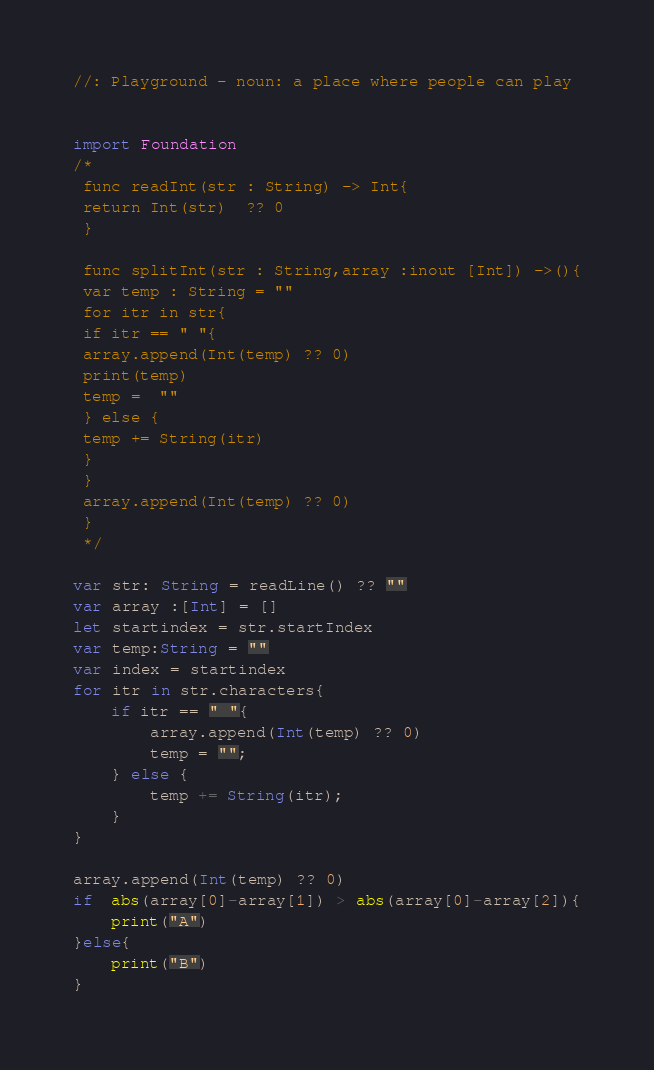<code> <loc_0><loc_0><loc_500><loc_500><_Swift_>//: Playground - noun: a place where people can play


import Foundation
/*
 func readInt(str : String) -> Int{
 return Int(str)  ?? 0
 }
 
 func splitInt(str : String,array :inout [Int]) ->(){
 var temp : String = ""
 for itr in str{
 if itr == " "{
 array.append(Int(temp) ?? 0)
 print(temp)
 temp =  ""
 } else {
 temp += String(itr)
 }
 }
 array.append(Int(temp) ?? 0)
 }
 */

var str: String = readLine() ?? ""
var array :[Int] = []
let startindex = str.startIndex
var temp:String = ""
var index = startindex
for itr in str.characters{
    if itr == " "{
        array.append(Int(temp) ?? 0)
        temp = "";
    } else {
        temp += String(itr);
    }
}

array.append(Int(temp) ?? 0)
if  abs(array[0]-array[1]) > abs(array[0]-array[2]){
    print("A")
}else{
    print("B")
}

</code> 